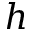Convert formula to latex. <formula><loc_0><loc_0><loc_500><loc_500>h</formula> 